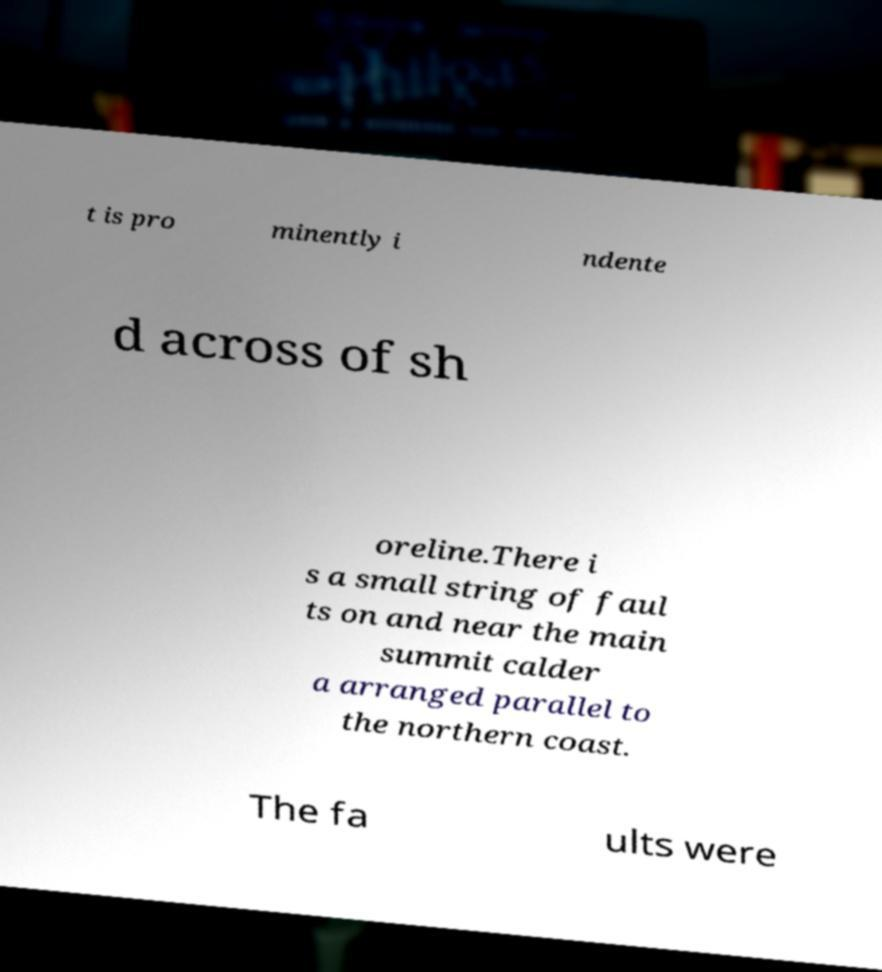What messages or text are displayed in this image? I need them in a readable, typed format. t is pro minently i ndente d across of sh oreline.There i s a small string of faul ts on and near the main summit calder a arranged parallel to the northern coast. The fa ults were 